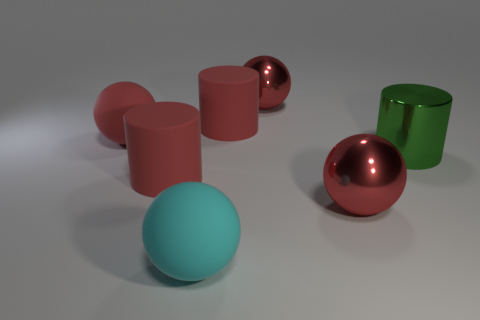There is a large metal thing that is behind the green cylinder; what color is it?
Provide a short and direct response. Red. There is a red matte sphere; are there any big red objects in front of it?
Your response must be concise. Yes. Are there more big green cylinders than large red cylinders?
Ensure brevity in your answer.  No. What is the color of the cylinder that is right of the big metallic ball that is behind the big rubber cylinder behind the red matte sphere?
Your answer should be compact. Green. Is there any other thing that is the same size as the green cylinder?
Make the answer very short. Yes. How many objects are either big balls behind the green cylinder or big balls on the right side of the cyan matte ball?
Make the answer very short. 3. There is a red rubber cylinder that is on the left side of the large cyan object; does it have the same size as the shiny cylinder that is on the right side of the cyan thing?
Make the answer very short. Yes. The other big rubber thing that is the same shape as the cyan thing is what color?
Ensure brevity in your answer.  Red. Is there any other thing that is the same shape as the large green object?
Ensure brevity in your answer.  Yes. Are there more green metallic cylinders that are on the right side of the cyan rubber ball than things that are in front of the metal cylinder?
Make the answer very short. No. 